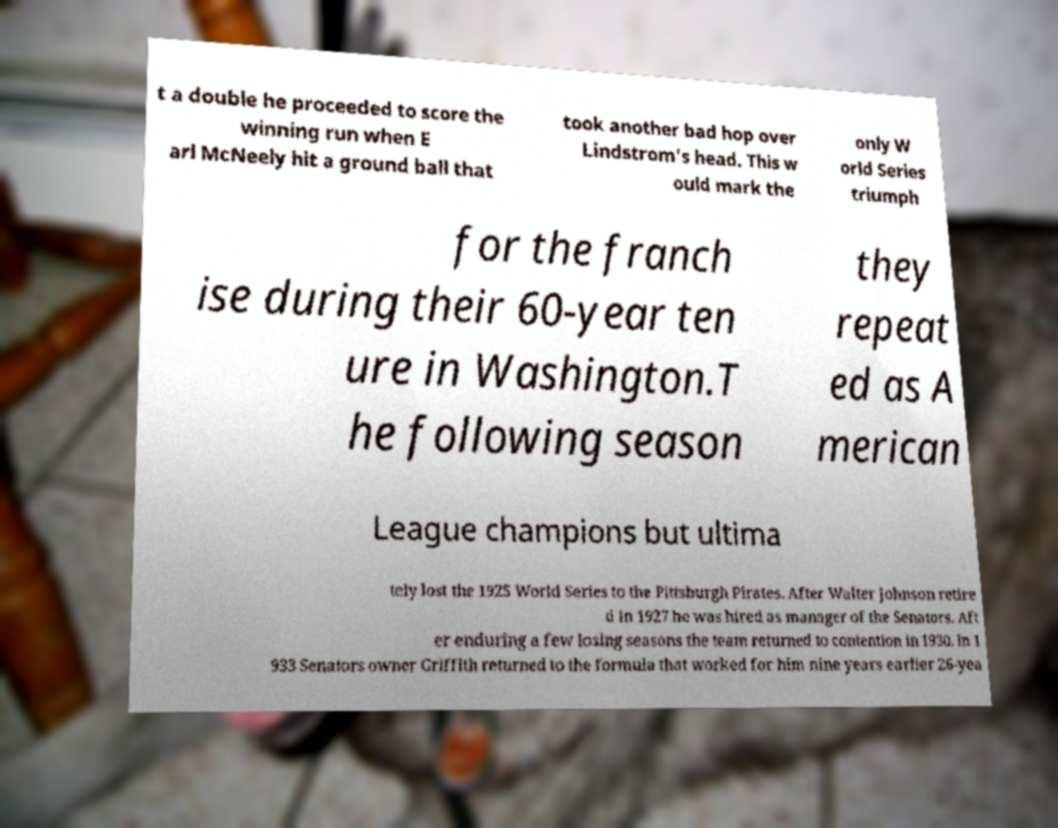What messages or text are displayed in this image? I need them in a readable, typed format. t a double he proceeded to score the winning run when E arl McNeely hit a ground ball that took another bad hop over Lindstrom's head. This w ould mark the only W orld Series triumph for the franch ise during their 60-year ten ure in Washington.T he following season they repeat ed as A merican League champions but ultima tely lost the 1925 World Series to the Pittsburgh Pirates. After Walter Johnson retire d in 1927 he was hired as manager of the Senators. Aft er enduring a few losing seasons the team returned to contention in 1930. In 1 933 Senators owner Griffith returned to the formula that worked for him nine years earlier 26-yea 